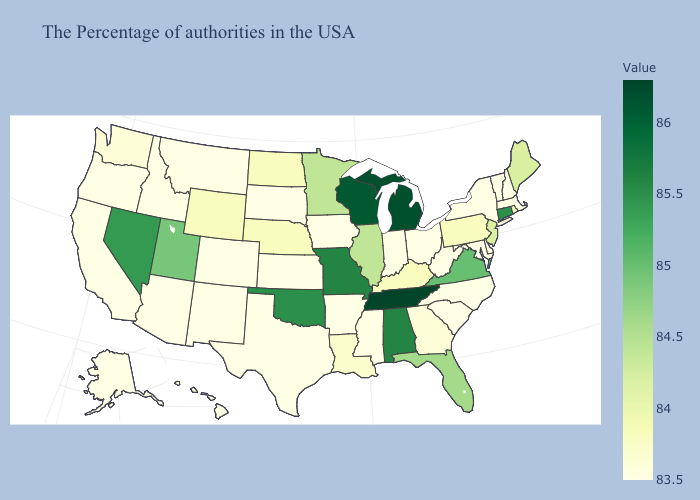Which states hav the highest value in the South?
Keep it brief. Tennessee. Among the states that border Florida , does Georgia have the highest value?
Short answer required. No. Does the map have missing data?
Quick response, please. No. Does Pennsylvania have a higher value than South Dakota?
Answer briefly. Yes. 